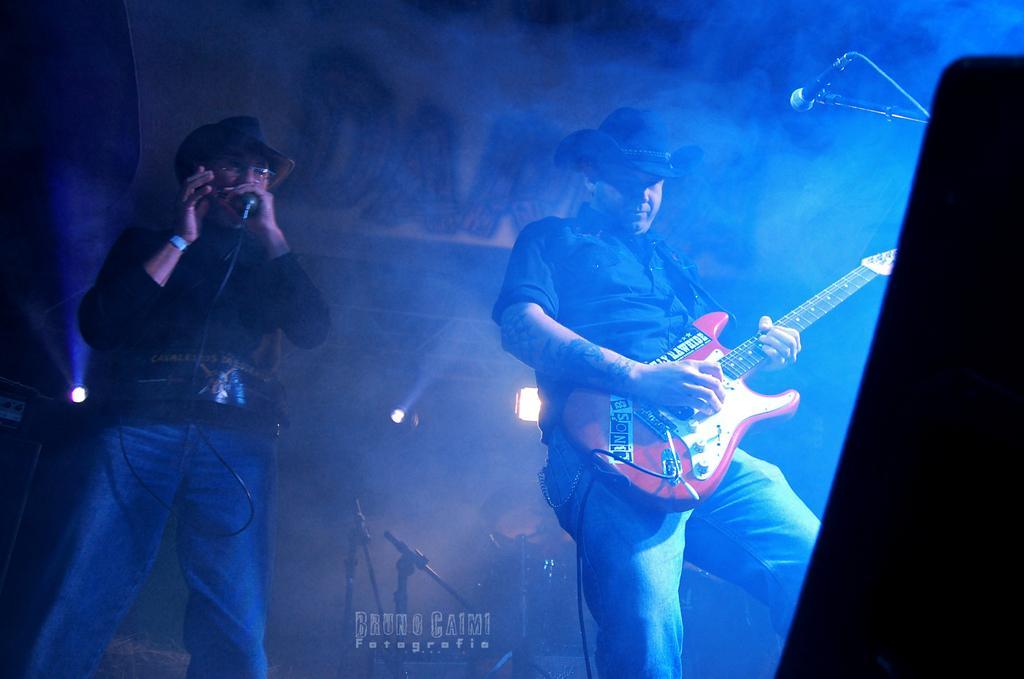Please provide a concise description of this image. Image has two persons standing. Person at the right side is holding a guitar is wearing a hat. Person at the left side is holding a mike is wearing a hat. At the right side there is a mike. At the back side there is light and stands. 